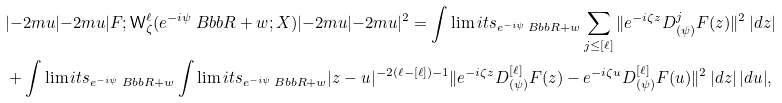Convert formula to latex. <formula><loc_0><loc_0><loc_500><loc_500>& | { - 2 m u } | { - 2 m u } | F ; \mathsf W ^ { \ell } _ { \zeta } ( e ^ { - i \psi } \ B b b R + w ; X ) | { - 2 m u } | { - 2 m u } | ^ { 2 } = \int \lim i t s _ { e ^ { - i \psi } \ B b b R + w } \sum _ { j \leq [ \ell ] } \| e ^ { - i \zeta z } D ^ { j } _ { ( \psi ) } F ( z ) \| ^ { 2 } \, | d z | \\ & + \int \lim i t s _ { e ^ { - i \psi } \ B b b R + w } \int \lim i t s _ { e ^ { - i \psi } \ B b b R + w } | z - u | ^ { - 2 ( \ell - [ \ell ] ) - 1 } \| e ^ { - i \zeta z } D ^ { [ \ell ] } _ { ( \psi ) } F ( z ) - e ^ { - i \zeta u } D ^ { [ \ell ] } _ { ( \psi ) } F ( u ) \| ^ { 2 } \, | d z | \, | d u | ,</formula> 